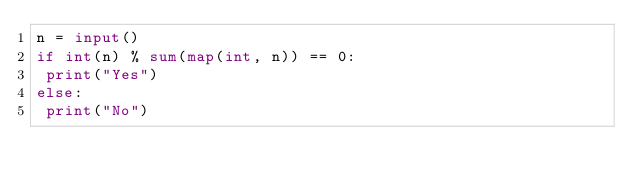Convert code to text. <code><loc_0><loc_0><loc_500><loc_500><_Python_>n = input()
if int(n) % sum(map(int, n)) == 0:
 print("Yes")
else:
 print("No")</code> 